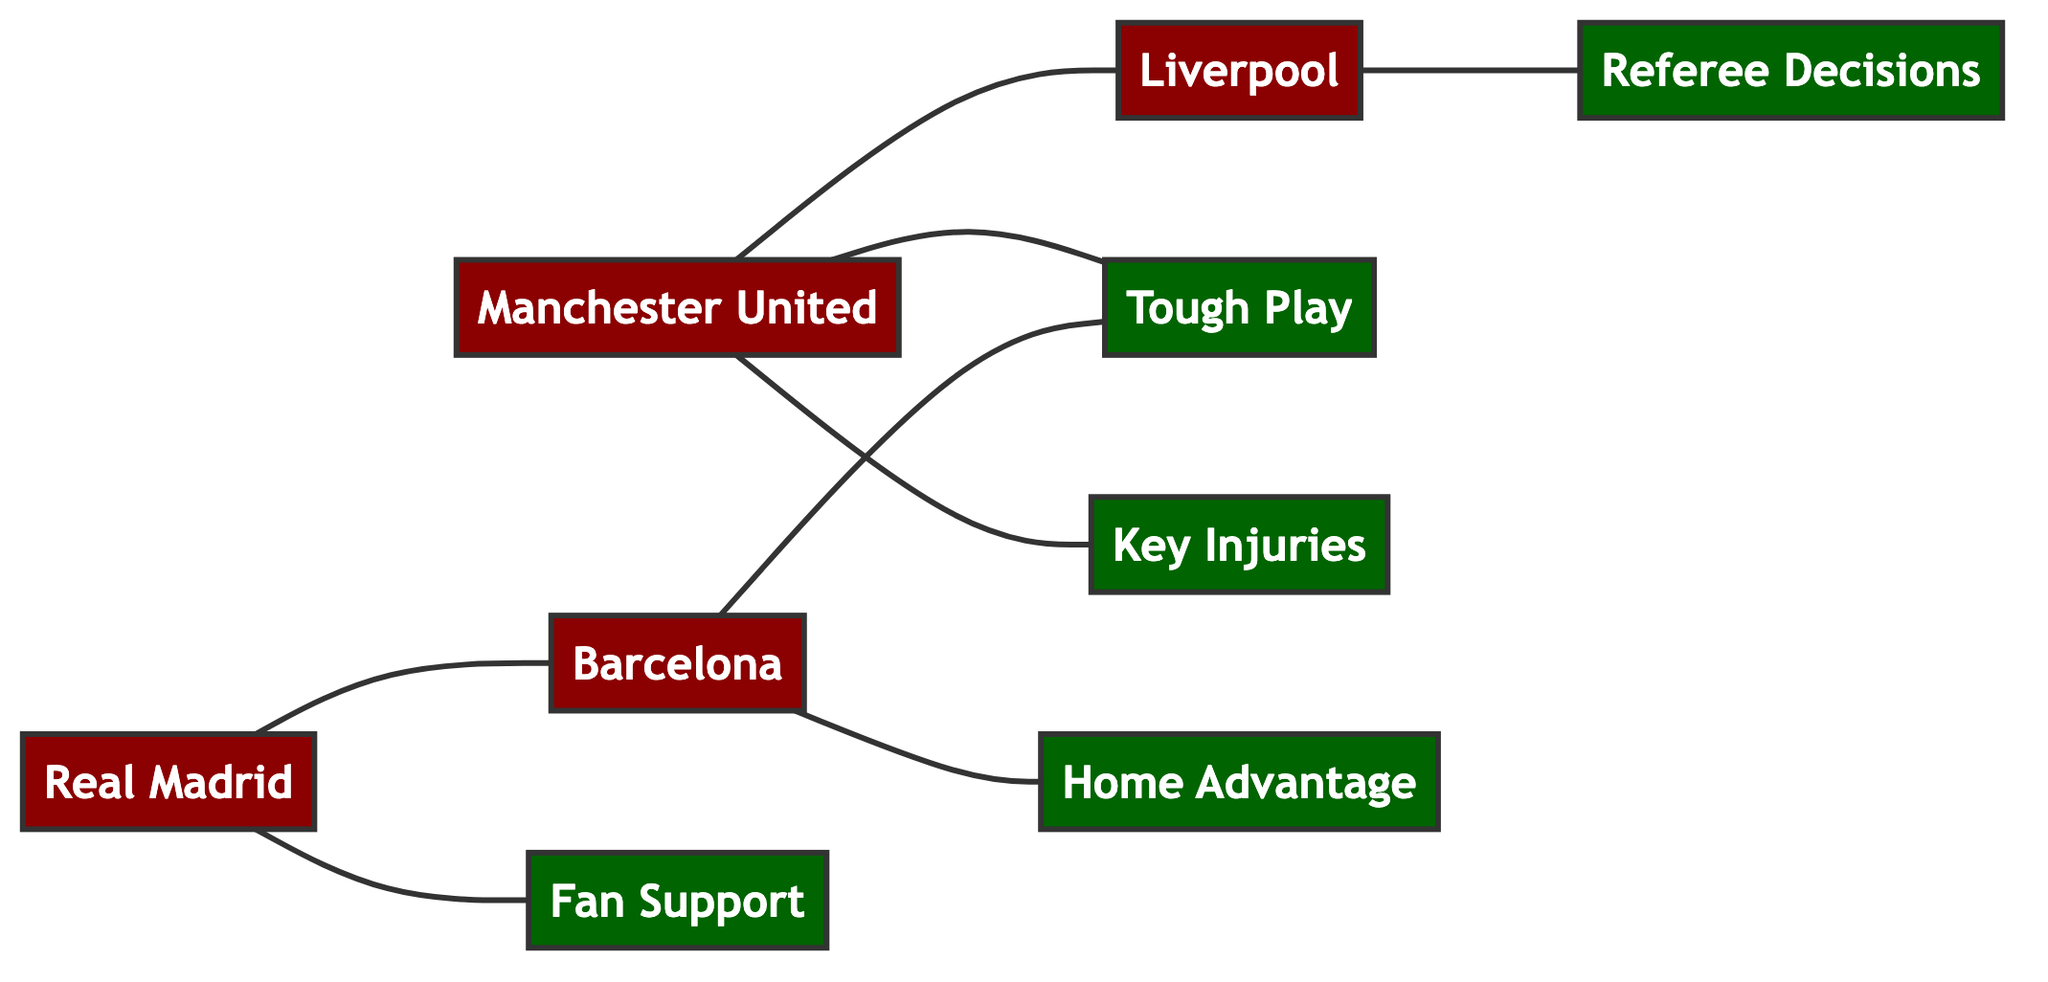What's the total number of teams in the diagram? The diagram contains four distinct team nodes: Manchester United, Liverpool, Real Madrid, and Barcelona. Counting these gives a total of four teams.
Answer: 4 Which two teams are connected in the diagram? The connections in the diagram indicate that Manchester United is connected to Liverpool, and Real Madrid is connected to Barcelona. These connections showcase rivalries or historical match outcomes.
Answer: Manchester United and Liverpool, Real Madrid and Barcelona What is the relationship between Manchester United and Tough Play? The diagram shows a direct connection between Manchester United and Tough Play, representing that tough play is a factor associated with Manchester United's outcomes.
Answer: Tough Play How many factors are represented in the graph? There are five distinct factors represented as nodes in the diagram: Tough Play, Key Injuries, Home Advantage, Referee Decisions, and Fan Support. Counting these gives a total of five factors.
Answer: 5 What does the edge connecting Real Madrid and Fan Support signify? The edge shows a relationship indicating that Fan Support is an influential factor in the outcomes associated with Real Madrid. This suggests that the support of fans can significantly impact match results for this team.
Answer: Fan Support Which team is associated with Home Advantage? Barcelona is the team that has a direct connection to Home Advantage in the diagram, suggesting a relationship where playing at home is an advantage for this team.
Answer: Barcelona What can you infer about the connection between Liverpool and Referee Decisions? The connection indicates that Referee Decisions are an influential factor for Liverpool, implying that match outcomes might be affected by the decisions made by referees in their games.
Answer: Referee Decisions Are there any teams connected to more than one factor? Yes, both Manchester United and Barcelona are connected to Tough Play, while Manchester United is also connected to Key Injuries, indicating that multiple factors influence their match outcomes.
Answer: Yes, Manchester United and Barcelona Who is connected to Key Injuries? In the diagram, Manchester United is the only team with a direct link to Key Injuries, indicating that injuries to key players might impact their performance in matches.
Answer: Manchester United 